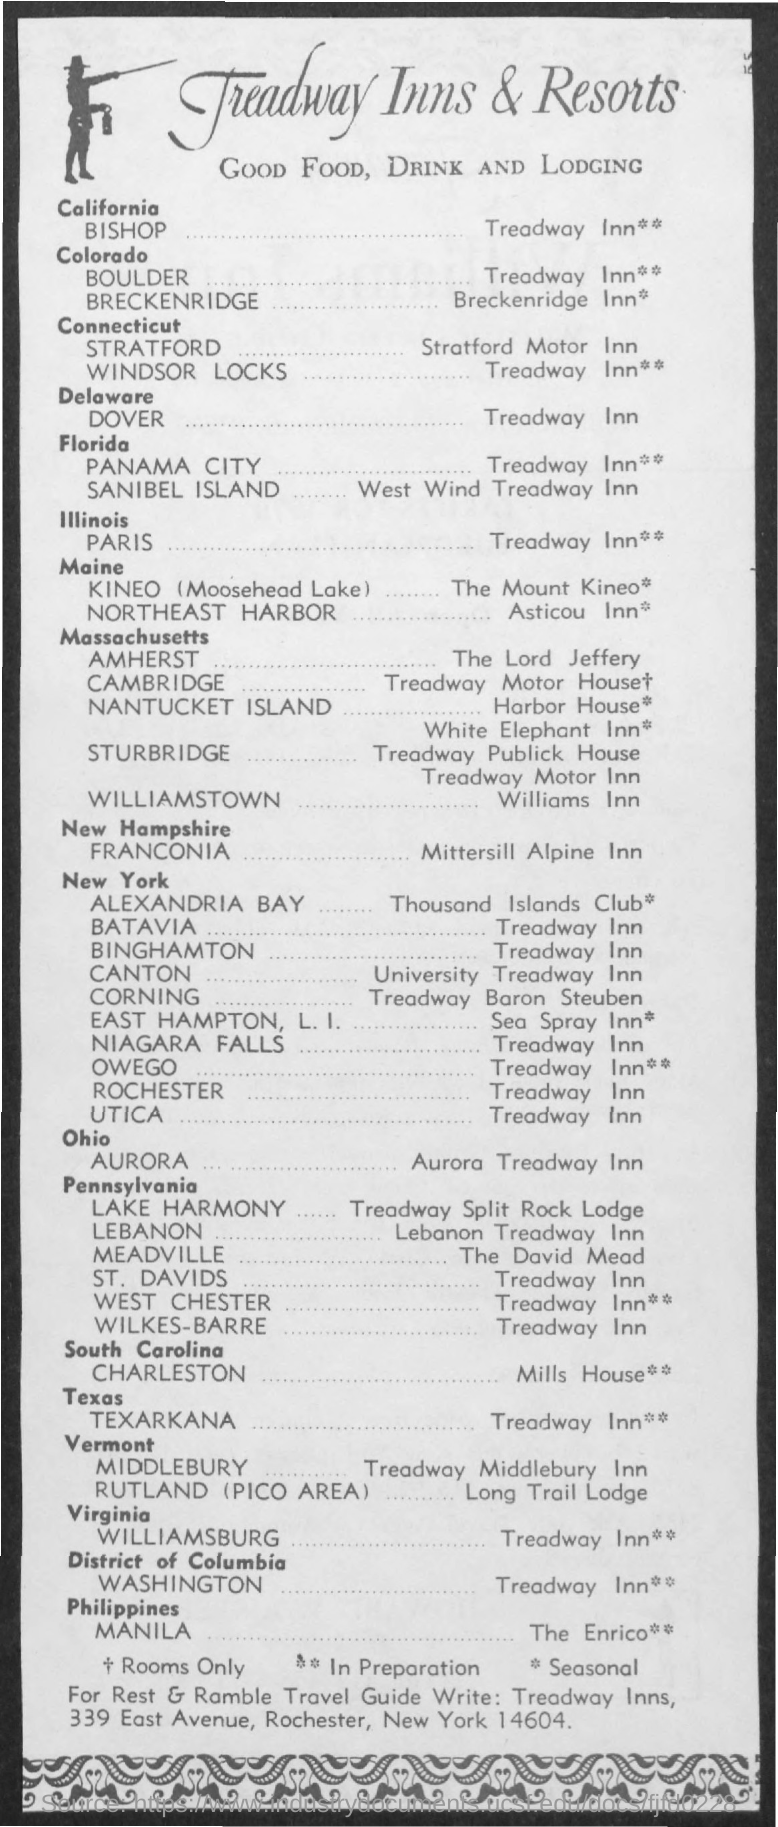Indicate a few pertinent items in this graphic. The name of the resort is Treadway Inns & Resorts. 